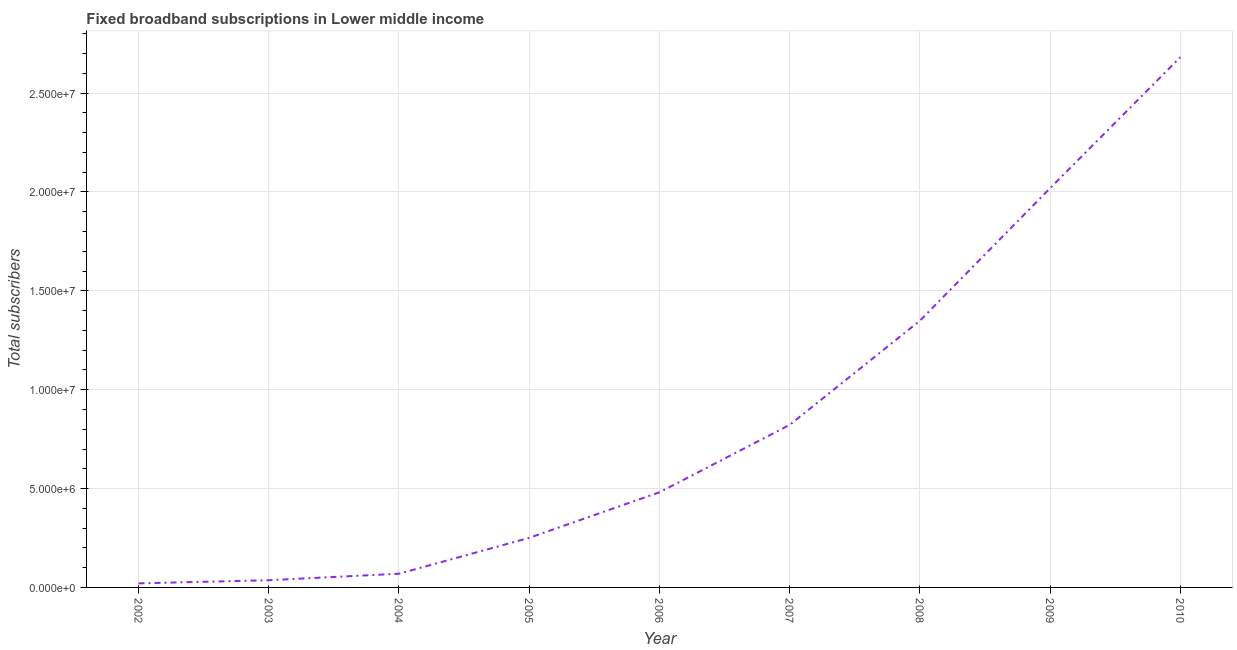What is the total number of fixed broadband subscriptions in 2005?
Your answer should be very brief. 2.51e+06. Across all years, what is the maximum total number of fixed broadband subscriptions?
Provide a short and direct response. 2.68e+07. Across all years, what is the minimum total number of fixed broadband subscriptions?
Ensure brevity in your answer.  2.05e+05. What is the sum of the total number of fixed broadband subscriptions?
Ensure brevity in your answer.  7.73e+07. What is the difference between the total number of fixed broadband subscriptions in 2007 and 2010?
Keep it short and to the point. -1.86e+07. What is the average total number of fixed broadband subscriptions per year?
Provide a short and direct response. 8.59e+06. What is the median total number of fixed broadband subscriptions?
Offer a very short reply. 4.81e+06. Do a majority of the years between 2009 and 2004 (inclusive) have total number of fixed broadband subscriptions greater than 15000000 ?
Your answer should be compact. Yes. What is the ratio of the total number of fixed broadband subscriptions in 2002 to that in 2003?
Provide a short and direct response. 0.56. Is the difference between the total number of fixed broadband subscriptions in 2005 and 2008 greater than the difference between any two years?
Keep it short and to the point. No. What is the difference between the highest and the second highest total number of fixed broadband subscriptions?
Your answer should be very brief. 6.62e+06. Is the sum of the total number of fixed broadband subscriptions in 2002 and 2009 greater than the maximum total number of fixed broadband subscriptions across all years?
Offer a terse response. No. What is the difference between the highest and the lowest total number of fixed broadband subscriptions?
Give a very brief answer. 2.66e+07. How many years are there in the graph?
Keep it short and to the point. 9. Are the values on the major ticks of Y-axis written in scientific E-notation?
Give a very brief answer. Yes. What is the title of the graph?
Make the answer very short. Fixed broadband subscriptions in Lower middle income. What is the label or title of the X-axis?
Your answer should be very brief. Year. What is the label or title of the Y-axis?
Your answer should be compact. Total subscribers. What is the Total subscribers in 2002?
Your response must be concise. 2.05e+05. What is the Total subscribers of 2003?
Ensure brevity in your answer.  3.65e+05. What is the Total subscribers in 2004?
Give a very brief answer. 6.93e+05. What is the Total subscribers in 2005?
Keep it short and to the point. 2.51e+06. What is the Total subscribers in 2006?
Your answer should be very brief. 4.81e+06. What is the Total subscribers of 2007?
Offer a very short reply. 8.22e+06. What is the Total subscribers of 2008?
Offer a terse response. 1.35e+07. What is the Total subscribers of 2009?
Your response must be concise. 2.02e+07. What is the Total subscribers in 2010?
Provide a short and direct response. 2.68e+07. What is the difference between the Total subscribers in 2002 and 2003?
Make the answer very short. -1.60e+05. What is the difference between the Total subscribers in 2002 and 2004?
Keep it short and to the point. -4.89e+05. What is the difference between the Total subscribers in 2002 and 2005?
Give a very brief answer. -2.30e+06. What is the difference between the Total subscribers in 2002 and 2006?
Your response must be concise. -4.61e+06. What is the difference between the Total subscribers in 2002 and 2007?
Ensure brevity in your answer.  -8.02e+06. What is the difference between the Total subscribers in 2002 and 2008?
Keep it short and to the point. -1.33e+07. What is the difference between the Total subscribers in 2002 and 2009?
Offer a terse response. -2.00e+07. What is the difference between the Total subscribers in 2002 and 2010?
Offer a terse response. -2.66e+07. What is the difference between the Total subscribers in 2003 and 2004?
Offer a terse response. -3.29e+05. What is the difference between the Total subscribers in 2003 and 2005?
Ensure brevity in your answer.  -2.14e+06. What is the difference between the Total subscribers in 2003 and 2006?
Keep it short and to the point. -4.45e+06. What is the difference between the Total subscribers in 2003 and 2007?
Make the answer very short. -7.86e+06. What is the difference between the Total subscribers in 2003 and 2008?
Offer a very short reply. -1.31e+07. What is the difference between the Total subscribers in 2003 and 2009?
Ensure brevity in your answer.  -1.98e+07. What is the difference between the Total subscribers in 2003 and 2010?
Make the answer very short. -2.65e+07. What is the difference between the Total subscribers in 2004 and 2005?
Offer a very short reply. -1.81e+06. What is the difference between the Total subscribers in 2004 and 2006?
Provide a short and direct response. -4.12e+06. What is the difference between the Total subscribers in 2004 and 2007?
Ensure brevity in your answer.  -7.53e+06. What is the difference between the Total subscribers in 2004 and 2008?
Keep it short and to the point. -1.28e+07. What is the difference between the Total subscribers in 2004 and 2009?
Make the answer very short. -1.95e+07. What is the difference between the Total subscribers in 2004 and 2010?
Your response must be concise. -2.61e+07. What is the difference between the Total subscribers in 2005 and 2006?
Provide a short and direct response. -2.30e+06. What is the difference between the Total subscribers in 2005 and 2007?
Provide a succinct answer. -5.71e+06. What is the difference between the Total subscribers in 2005 and 2008?
Make the answer very short. -1.10e+07. What is the difference between the Total subscribers in 2005 and 2009?
Your answer should be compact. -1.77e+07. What is the difference between the Total subscribers in 2005 and 2010?
Your answer should be compact. -2.43e+07. What is the difference between the Total subscribers in 2006 and 2007?
Provide a short and direct response. -3.41e+06. What is the difference between the Total subscribers in 2006 and 2008?
Your answer should be compact. -8.68e+06. What is the difference between the Total subscribers in 2006 and 2009?
Your answer should be compact. -1.54e+07. What is the difference between the Total subscribers in 2006 and 2010?
Your answer should be compact. -2.20e+07. What is the difference between the Total subscribers in 2007 and 2008?
Ensure brevity in your answer.  -5.27e+06. What is the difference between the Total subscribers in 2007 and 2009?
Give a very brief answer. -1.20e+07. What is the difference between the Total subscribers in 2007 and 2010?
Your answer should be very brief. -1.86e+07. What is the difference between the Total subscribers in 2008 and 2009?
Your answer should be compact. -6.70e+06. What is the difference between the Total subscribers in 2008 and 2010?
Your answer should be compact. -1.33e+07. What is the difference between the Total subscribers in 2009 and 2010?
Your answer should be very brief. -6.62e+06. What is the ratio of the Total subscribers in 2002 to that in 2003?
Your response must be concise. 0.56. What is the ratio of the Total subscribers in 2002 to that in 2004?
Offer a terse response. 0.29. What is the ratio of the Total subscribers in 2002 to that in 2005?
Provide a short and direct response. 0.08. What is the ratio of the Total subscribers in 2002 to that in 2006?
Your answer should be very brief. 0.04. What is the ratio of the Total subscribers in 2002 to that in 2007?
Give a very brief answer. 0.03. What is the ratio of the Total subscribers in 2002 to that in 2008?
Offer a terse response. 0.01. What is the ratio of the Total subscribers in 2002 to that in 2009?
Your response must be concise. 0.01. What is the ratio of the Total subscribers in 2002 to that in 2010?
Ensure brevity in your answer.  0.01. What is the ratio of the Total subscribers in 2003 to that in 2004?
Provide a succinct answer. 0.53. What is the ratio of the Total subscribers in 2003 to that in 2005?
Give a very brief answer. 0.14. What is the ratio of the Total subscribers in 2003 to that in 2006?
Provide a short and direct response. 0.08. What is the ratio of the Total subscribers in 2003 to that in 2007?
Provide a short and direct response. 0.04. What is the ratio of the Total subscribers in 2003 to that in 2008?
Provide a short and direct response. 0.03. What is the ratio of the Total subscribers in 2003 to that in 2009?
Ensure brevity in your answer.  0.02. What is the ratio of the Total subscribers in 2003 to that in 2010?
Provide a short and direct response. 0.01. What is the ratio of the Total subscribers in 2004 to that in 2005?
Provide a succinct answer. 0.28. What is the ratio of the Total subscribers in 2004 to that in 2006?
Offer a terse response. 0.14. What is the ratio of the Total subscribers in 2004 to that in 2007?
Make the answer very short. 0.08. What is the ratio of the Total subscribers in 2004 to that in 2008?
Make the answer very short. 0.05. What is the ratio of the Total subscribers in 2004 to that in 2009?
Give a very brief answer. 0.03. What is the ratio of the Total subscribers in 2004 to that in 2010?
Offer a terse response. 0.03. What is the ratio of the Total subscribers in 2005 to that in 2006?
Give a very brief answer. 0.52. What is the ratio of the Total subscribers in 2005 to that in 2007?
Your answer should be compact. 0.3. What is the ratio of the Total subscribers in 2005 to that in 2008?
Make the answer very short. 0.19. What is the ratio of the Total subscribers in 2005 to that in 2009?
Your response must be concise. 0.12. What is the ratio of the Total subscribers in 2005 to that in 2010?
Give a very brief answer. 0.09. What is the ratio of the Total subscribers in 2006 to that in 2007?
Your answer should be compact. 0.58. What is the ratio of the Total subscribers in 2006 to that in 2008?
Offer a very short reply. 0.36. What is the ratio of the Total subscribers in 2006 to that in 2009?
Make the answer very short. 0.24. What is the ratio of the Total subscribers in 2006 to that in 2010?
Provide a succinct answer. 0.18. What is the ratio of the Total subscribers in 2007 to that in 2008?
Make the answer very short. 0.61. What is the ratio of the Total subscribers in 2007 to that in 2009?
Provide a short and direct response. 0.41. What is the ratio of the Total subscribers in 2007 to that in 2010?
Give a very brief answer. 0.31. What is the ratio of the Total subscribers in 2008 to that in 2009?
Offer a terse response. 0.67. What is the ratio of the Total subscribers in 2008 to that in 2010?
Give a very brief answer. 0.5. What is the ratio of the Total subscribers in 2009 to that in 2010?
Your answer should be very brief. 0.75. 